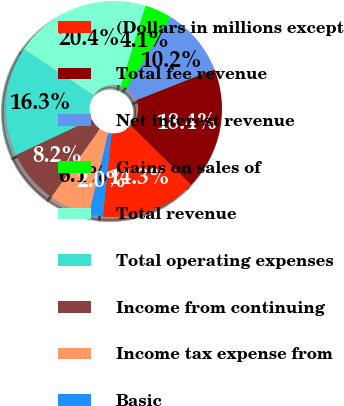Convert chart to OTSL. <chart><loc_0><loc_0><loc_500><loc_500><pie_chart><fcel>(Dollars in millions except<fcel>Total fee revenue<fcel>Net interest revenue<fcel>Gains on sales of<fcel>Total revenue<fcel>Total operating expenses<fcel>Income from continuing<fcel>Income tax expense from<fcel>Basic<nl><fcel>14.28%<fcel>18.36%<fcel>10.2%<fcel>4.09%<fcel>20.4%<fcel>16.32%<fcel>8.17%<fcel>6.13%<fcel>2.05%<nl></chart> 